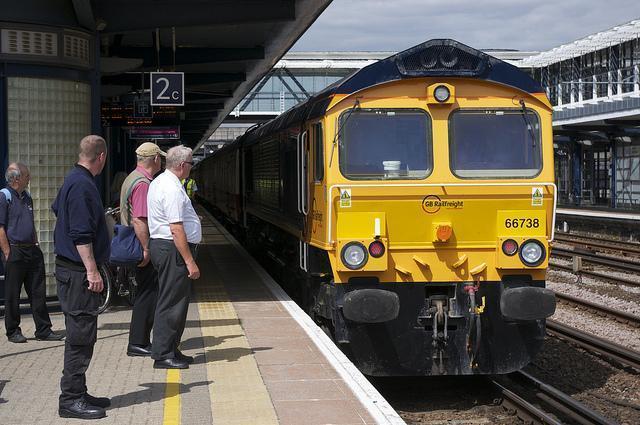How many people are waiting to get on the train?
Give a very brief answer. 4. How many people are there?
Give a very brief answer. 4. 